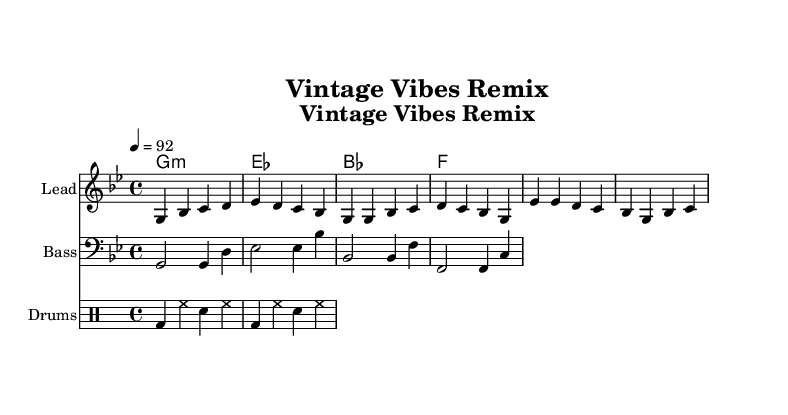What is the key signature of this music? The key signature is G minor, which has two flats (B♭ and E♭).
Answer: G minor What is the time signature of this piece? The time signature is 4/4, indicating that there are four beats in each measure and the quarter note gets one beat.
Answer: 4/4 What is the tempo marking indicated in the score? The tempo marking is 92 beats per minute, which tells us the pace of the piece.
Answer: 92 How many measures are present in the melody section? The melody section consists of four measures for the introduction, four for the verse, and four for the chorus, totaling twelve measures.
Answer: 12 What type of drum pattern is used in this piece? The drum pattern uses a combination of bass drum, hi-hat, and snare, which is typical for hip hop rhythms.
Answer: Hip hop rhythm What do the chord symbols represent in this piece? The chord symbols represent the harmonic structure of the piece, specifically G minor, E♭ major, B♭ major, and F major chords.
Answer: G minor, E♭, B♭, F Which section of the music features the lead melody? The lead melody is featured in the introduction, verse, and chorus sections of the score.
Answer: Introduction, verse, chorus 